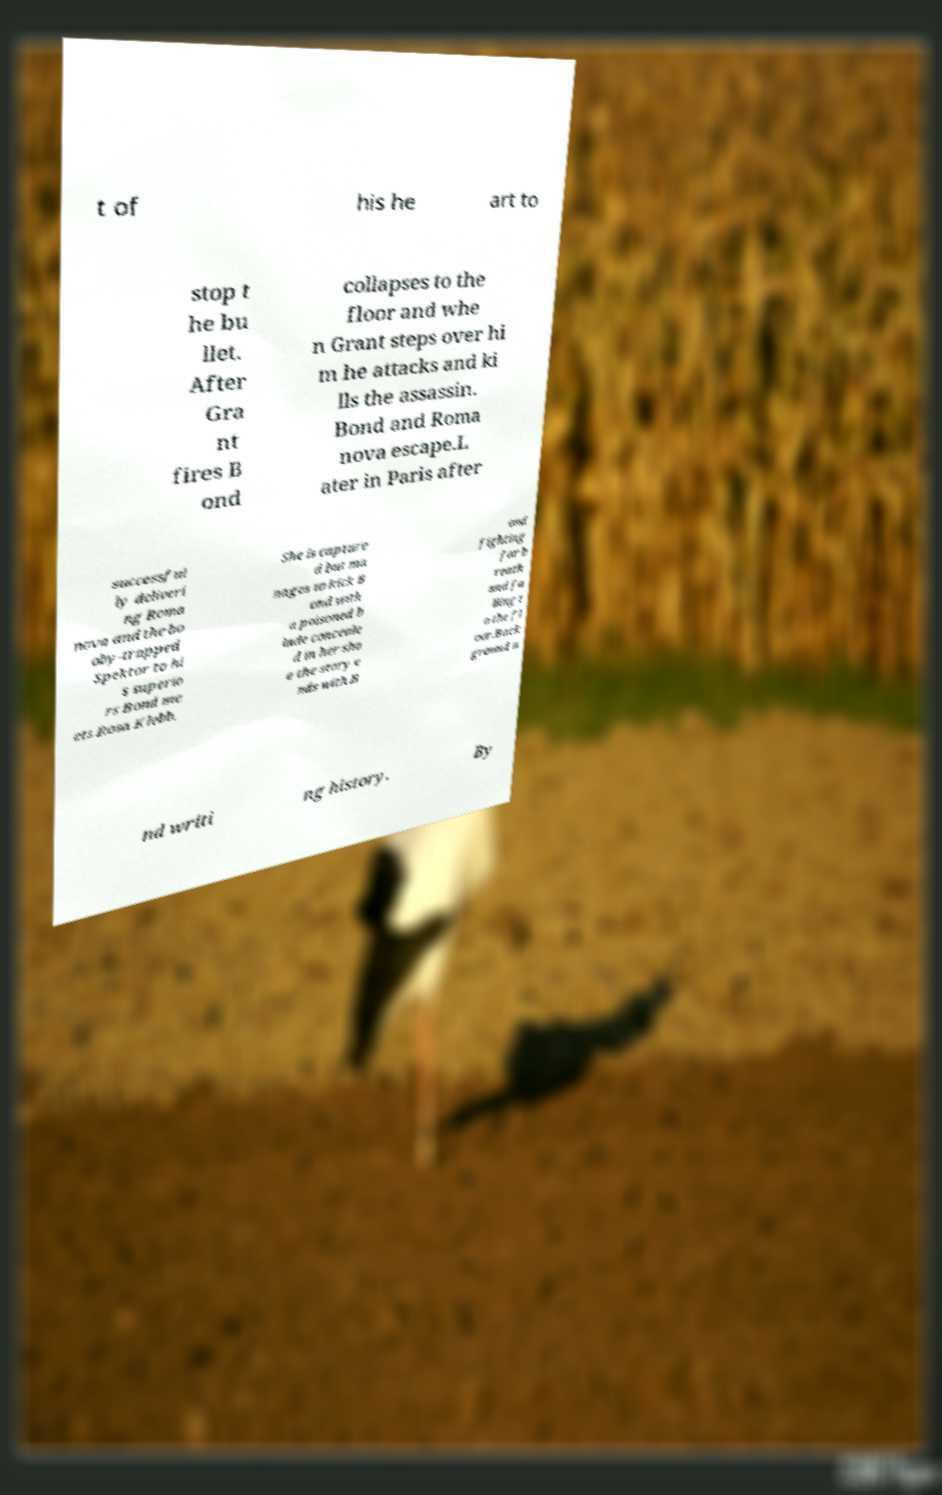Can you read and provide the text displayed in the image?This photo seems to have some interesting text. Can you extract and type it out for me? t of his he art to stop t he bu llet. After Gra nt fires B ond collapses to the floor and whe n Grant steps over hi m he attacks and ki lls the assassin. Bond and Roma nova escape.L ater in Paris after successful ly deliveri ng Roma nova and the bo oby-trapped Spektor to hi s superio rs Bond me ets Rosa Klebb. She is capture d but ma nages to kick B ond with a poisoned b lade conceale d in her sho e the story e nds with B ond fighting for b reath and fa lling t o the fl oor.Back ground a nd writi ng history. By 